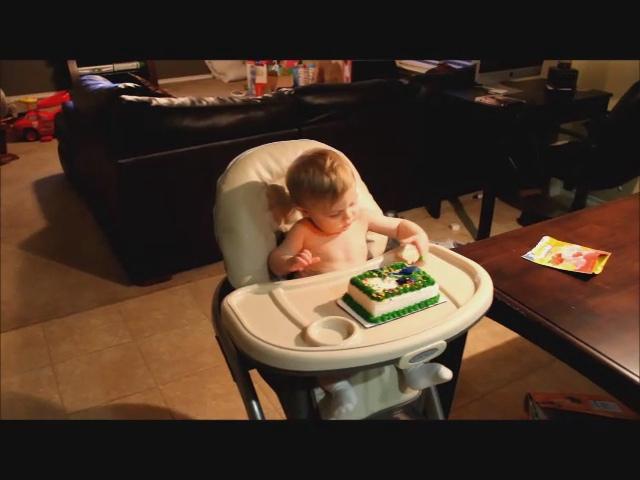Is this an adult?
Write a very short answer. No. What are they in?
Be succinct. High chair. Is the baby reading a book?
Quick response, please. No. What will the baby do with the cake other than eat it?
Be succinct. Play. 